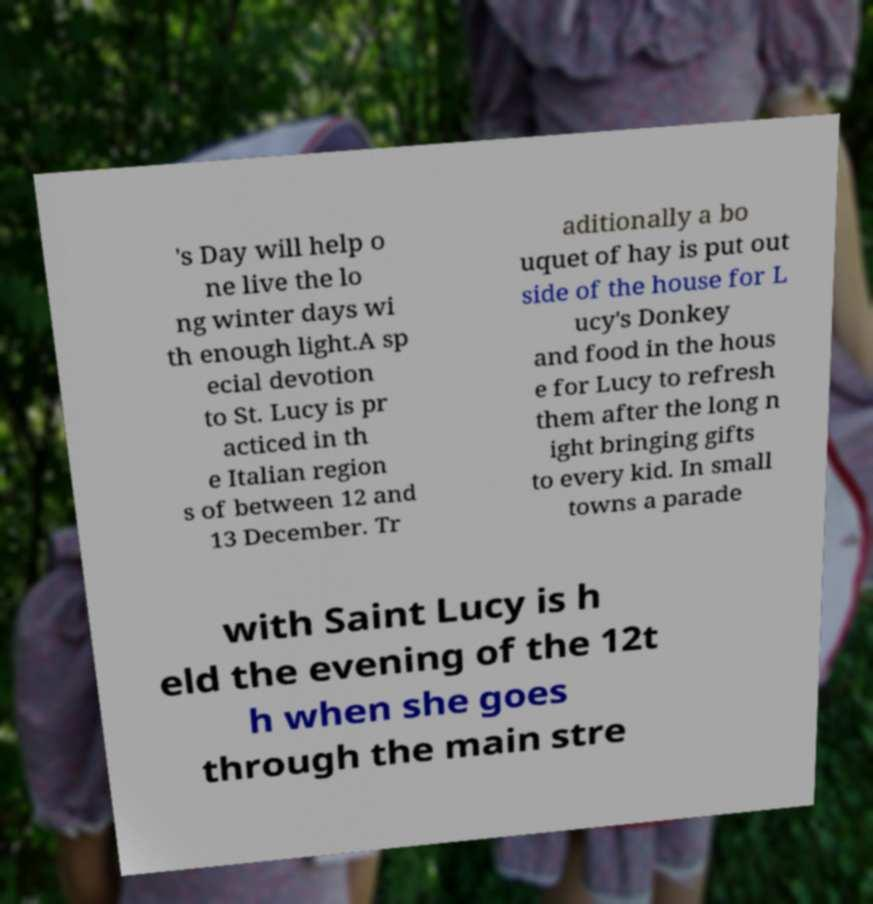Could you extract and type out the text from this image? 's Day will help o ne live the lo ng winter days wi th enough light.A sp ecial devotion to St. Lucy is pr acticed in th e Italian region s of between 12 and 13 December. Tr aditionally a bo uquet of hay is put out side of the house for L ucy's Donkey and food in the hous e for Lucy to refresh them after the long n ight bringing gifts to every kid. In small towns a parade with Saint Lucy is h eld the evening of the 12t h when she goes through the main stre 